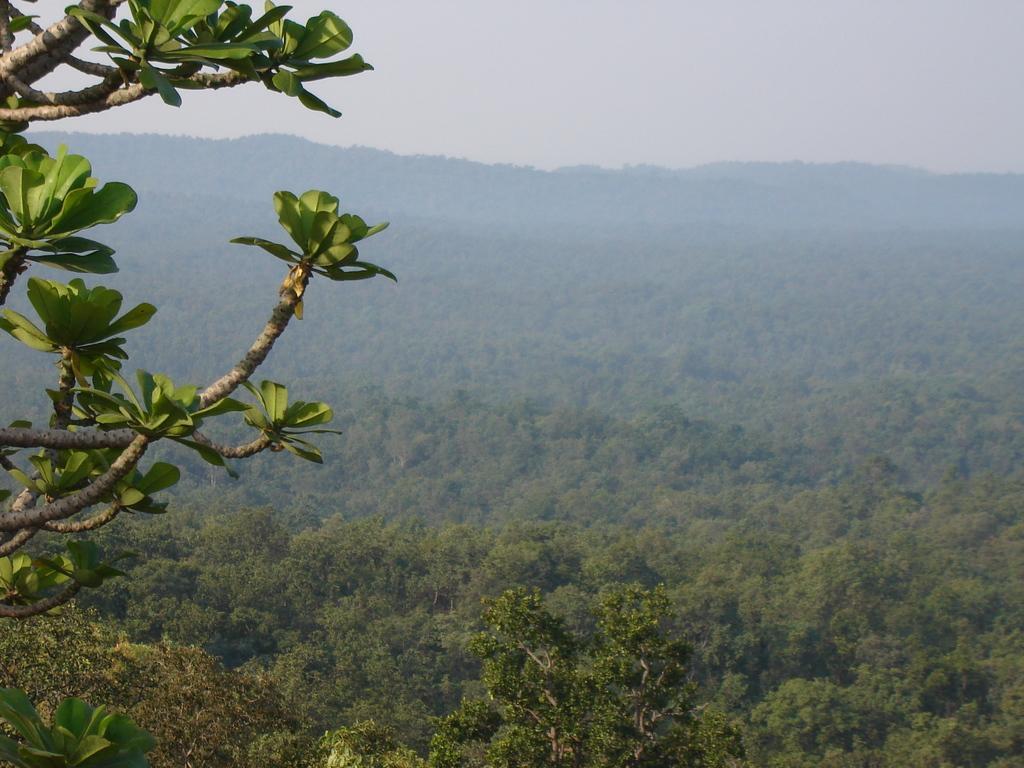How would you summarize this image in a sentence or two? On the left we can see leaves and branches of a tree. This is a picture which is looking like a forest. In this picture we can see trees. In the background at the top it is sky. 